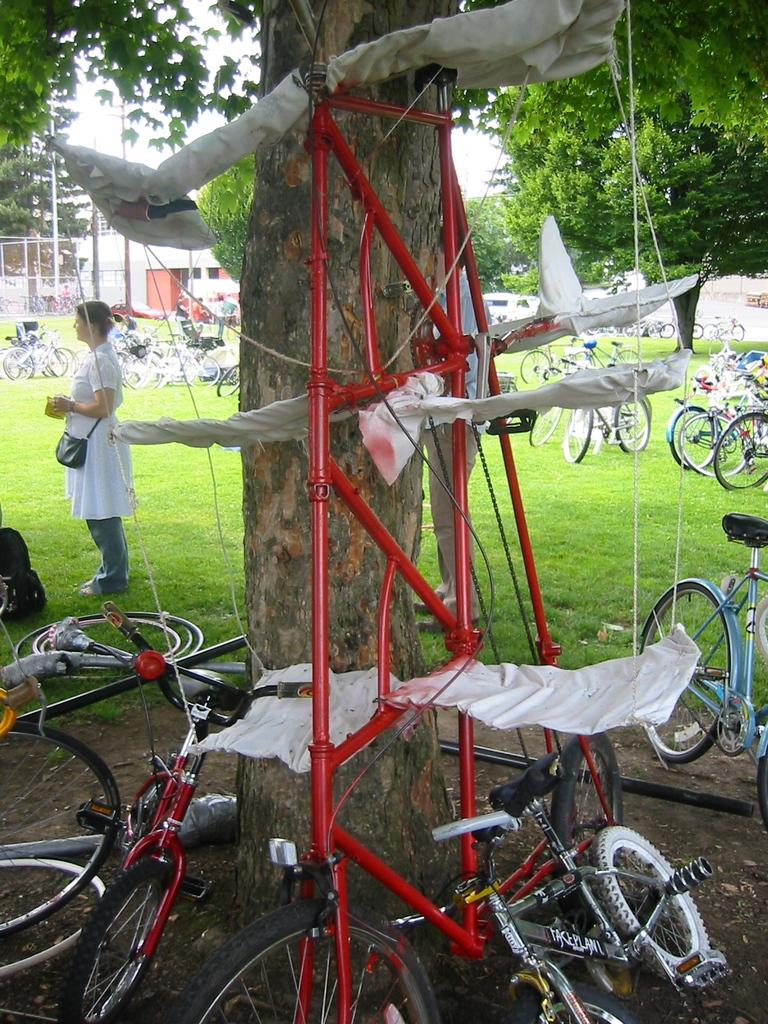What is the main object in the image? There is a tree in the image. What is surrounding the tree? There are cycles around the tree. What can be seen in the background of the image? There is a garden in the background of the image. What is present in the garden? There are cycles and trees in the garden. Who is in the image besides the tree and cycles? A woman is standing beside the tree. How many eggs are on the tree in the image? There are no eggs present on the tree in the image. What is the governor doing in the image? There is no governor present in the image. 